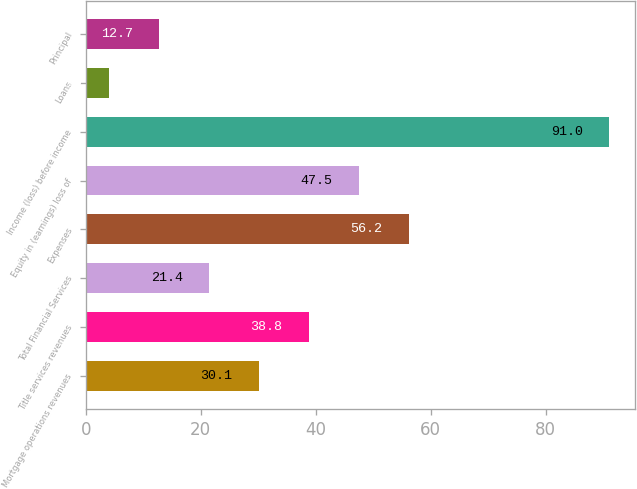Convert chart to OTSL. <chart><loc_0><loc_0><loc_500><loc_500><bar_chart><fcel>Mortgage operations revenues<fcel>Title services revenues<fcel>Total Financial Services<fcel>Expenses<fcel>Equity in (earnings) loss of<fcel>Income (loss) before income<fcel>Loans<fcel>Principal<nl><fcel>30.1<fcel>38.8<fcel>21.4<fcel>56.2<fcel>47.5<fcel>91<fcel>4<fcel>12.7<nl></chart> 